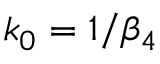<formula> <loc_0><loc_0><loc_500><loc_500>k _ { 0 } = 1 / \beta _ { 4 }</formula> 